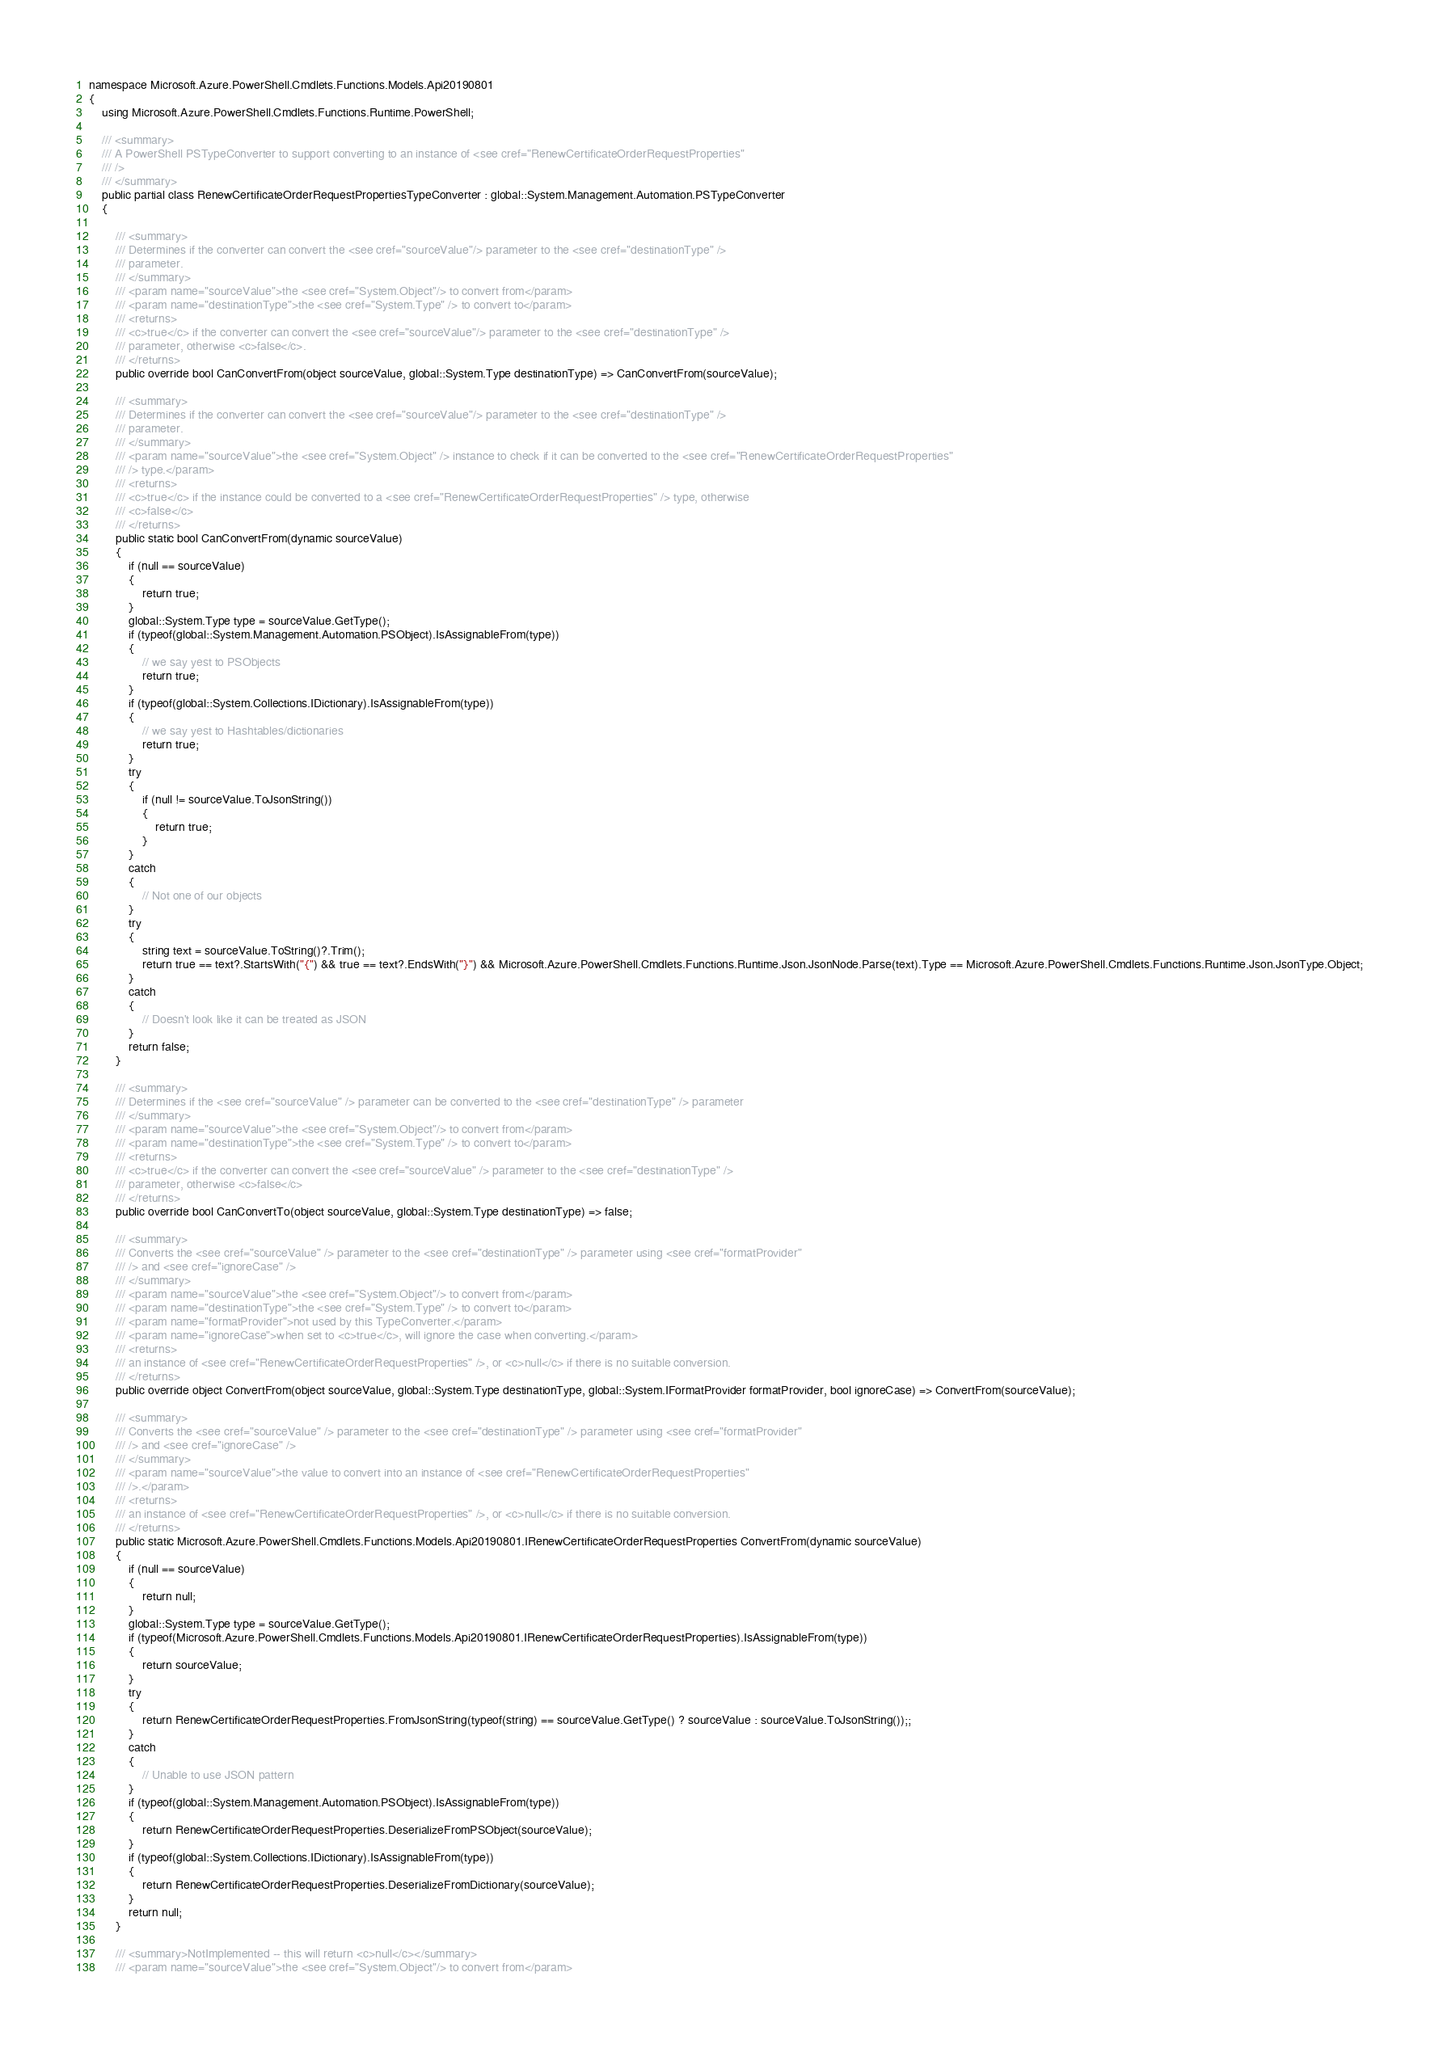Convert code to text. <code><loc_0><loc_0><loc_500><loc_500><_C#_>namespace Microsoft.Azure.PowerShell.Cmdlets.Functions.Models.Api20190801
{
    using Microsoft.Azure.PowerShell.Cmdlets.Functions.Runtime.PowerShell;

    /// <summary>
    /// A PowerShell PSTypeConverter to support converting to an instance of <see cref="RenewCertificateOrderRequestProperties"
    /// />
    /// </summary>
    public partial class RenewCertificateOrderRequestPropertiesTypeConverter : global::System.Management.Automation.PSTypeConverter
    {

        /// <summary>
        /// Determines if the converter can convert the <see cref="sourceValue"/> parameter to the <see cref="destinationType" />
        /// parameter.
        /// </summary>
        /// <param name="sourceValue">the <see cref="System.Object"/> to convert from</param>
        /// <param name="destinationType">the <see cref="System.Type" /> to convert to</param>
        /// <returns>
        /// <c>true</c> if the converter can convert the <see cref="sourceValue"/> parameter to the <see cref="destinationType" />
        /// parameter, otherwise <c>false</c>.
        /// </returns>
        public override bool CanConvertFrom(object sourceValue, global::System.Type destinationType) => CanConvertFrom(sourceValue);

        /// <summary>
        /// Determines if the converter can convert the <see cref="sourceValue"/> parameter to the <see cref="destinationType" />
        /// parameter.
        /// </summary>
        /// <param name="sourceValue">the <see cref="System.Object" /> instance to check if it can be converted to the <see cref="RenewCertificateOrderRequestProperties"
        /// /> type.</param>
        /// <returns>
        /// <c>true</c> if the instance could be converted to a <see cref="RenewCertificateOrderRequestProperties" /> type, otherwise
        /// <c>false</c>
        /// </returns>
        public static bool CanConvertFrom(dynamic sourceValue)
        {
            if (null == sourceValue)
            {
                return true;
            }
            global::System.Type type = sourceValue.GetType();
            if (typeof(global::System.Management.Automation.PSObject).IsAssignableFrom(type))
            {
                // we say yest to PSObjects
                return true;
            }
            if (typeof(global::System.Collections.IDictionary).IsAssignableFrom(type))
            {
                // we say yest to Hashtables/dictionaries
                return true;
            }
            try
            {
                if (null != sourceValue.ToJsonString())
                {
                    return true;
                }
            }
            catch
            {
                // Not one of our objects
            }
            try
            {
                string text = sourceValue.ToString()?.Trim();
                return true == text?.StartsWith("{") && true == text?.EndsWith("}") && Microsoft.Azure.PowerShell.Cmdlets.Functions.Runtime.Json.JsonNode.Parse(text).Type == Microsoft.Azure.PowerShell.Cmdlets.Functions.Runtime.Json.JsonType.Object;
            }
            catch
            {
                // Doesn't look like it can be treated as JSON
            }
            return false;
        }

        /// <summary>
        /// Determines if the <see cref="sourceValue" /> parameter can be converted to the <see cref="destinationType" /> parameter
        /// </summary>
        /// <param name="sourceValue">the <see cref="System.Object"/> to convert from</param>
        /// <param name="destinationType">the <see cref="System.Type" /> to convert to</param>
        /// <returns>
        /// <c>true</c> if the converter can convert the <see cref="sourceValue" /> parameter to the <see cref="destinationType" />
        /// parameter, otherwise <c>false</c>
        /// </returns>
        public override bool CanConvertTo(object sourceValue, global::System.Type destinationType) => false;

        /// <summary>
        /// Converts the <see cref="sourceValue" /> parameter to the <see cref="destinationType" /> parameter using <see cref="formatProvider"
        /// /> and <see cref="ignoreCase" />
        /// </summary>
        /// <param name="sourceValue">the <see cref="System.Object"/> to convert from</param>
        /// <param name="destinationType">the <see cref="System.Type" /> to convert to</param>
        /// <param name="formatProvider">not used by this TypeConverter.</param>
        /// <param name="ignoreCase">when set to <c>true</c>, will ignore the case when converting.</param>
        /// <returns>
        /// an instance of <see cref="RenewCertificateOrderRequestProperties" />, or <c>null</c> if there is no suitable conversion.
        /// </returns>
        public override object ConvertFrom(object sourceValue, global::System.Type destinationType, global::System.IFormatProvider formatProvider, bool ignoreCase) => ConvertFrom(sourceValue);

        /// <summary>
        /// Converts the <see cref="sourceValue" /> parameter to the <see cref="destinationType" /> parameter using <see cref="formatProvider"
        /// /> and <see cref="ignoreCase" />
        /// </summary>
        /// <param name="sourceValue">the value to convert into an instance of <see cref="RenewCertificateOrderRequestProperties"
        /// />.</param>
        /// <returns>
        /// an instance of <see cref="RenewCertificateOrderRequestProperties" />, or <c>null</c> if there is no suitable conversion.
        /// </returns>
        public static Microsoft.Azure.PowerShell.Cmdlets.Functions.Models.Api20190801.IRenewCertificateOrderRequestProperties ConvertFrom(dynamic sourceValue)
        {
            if (null == sourceValue)
            {
                return null;
            }
            global::System.Type type = sourceValue.GetType();
            if (typeof(Microsoft.Azure.PowerShell.Cmdlets.Functions.Models.Api20190801.IRenewCertificateOrderRequestProperties).IsAssignableFrom(type))
            {
                return sourceValue;
            }
            try
            {
                return RenewCertificateOrderRequestProperties.FromJsonString(typeof(string) == sourceValue.GetType() ? sourceValue : sourceValue.ToJsonString());;
            }
            catch
            {
                // Unable to use JSON pattern
            }
            if (typeof(global::System.Management.Automation.PSObject).IsAssignableFrom(type))
            {
                return RenewCertificateOrderRequestProperties.DeserializeFromPSObject(sourceValue);
            }
            if (typeof(global::System.Collections.IDictionary).IsAssignableFrom(type))
            {
                return RenewCertificateOrderRequestProperties.DeserializeFromDictionary(sourceValue);
            }
            return null;
        }

        /// <summary>NotImplemented -- this will return <c>null</c></summary>
        /// <param name="sourceValue">the <see cref="System.Object"/> to convert from</param></code> 